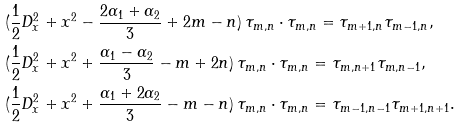<formula> <loc_0><loc_0><loc_500><loc_500>& ( \frac { 1 } { 2 } D _ { x } ^ { 2 } + x ^ { 2 } - \frac { 2 \alpha _ { 1 } + \alpha _ { 2 } } { 3 } + 2 m - n ) \, \tau _ { m , n } \cdot \tau _ { m , n } = \tau _ { m + 1 , n } \tau _ { m - 1 , n } , \\ & ( \frac { 1 } { 2 } D _ { x } ^ { 2 } + x ^ { 2 } + \frac { \alpha _ { 1 } - \alpha _ { 2 } } { 3 } - m + 2 n ) \, \tau _ { m , n } \cdot \tau _ { m , n } = \tau _ { m , n + 1 } \tau _ { m , n - 1 } , \\ & ( \frac { 1 } { 2 } D _ { x } ^ { 2 } + x ^ { 2 } + \frac { \alpha _ { 1 } + 2 \alpha _ { 2 } } { 3 } - m - n ) \, \tau _ { m , n } \cdot \tau _ { m , n } = \tau _ { m - 1 , n - 1 } \tau _ { m + 1 , n + 1 } .</formula> 